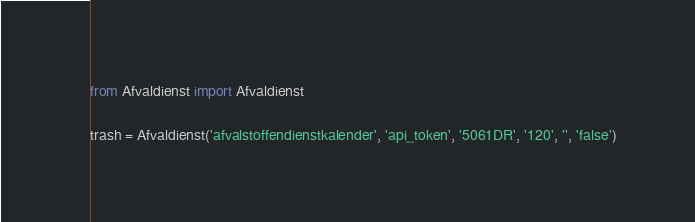<code> <loc_0><loc_0><loc_500><loc_500><_Python_>
from Afvaldienst import Afvaldienst

trash = Afvaldienst('afvalstoffendienstkalender', 'api_token', '5061DR', '120', '', 'false')
</code> 